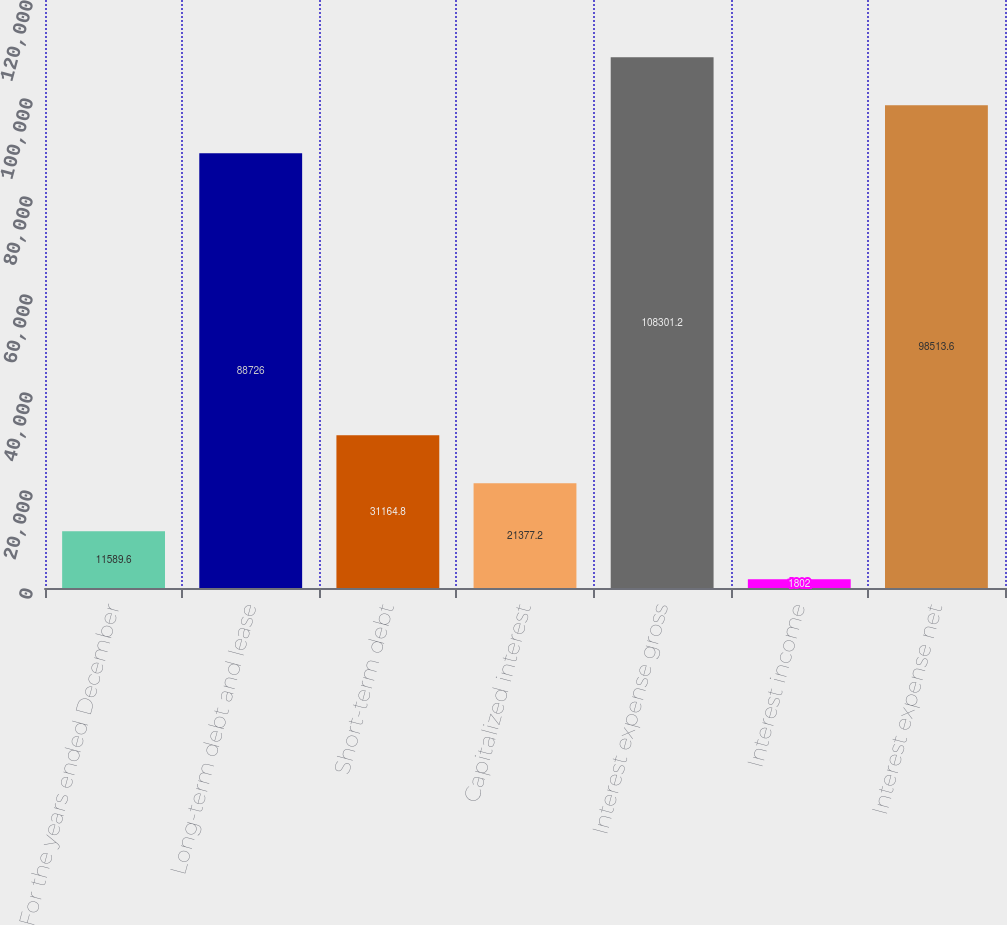<chart> <loc_0><loc_0><loc_500><loc_500><bar_chart><fcel>For the years ended December<fcel>Long-term debt and lease<fcel>Short-term debt<fcel>Capitalized interest<fcel>Interest expense gross<fcel>Interest income<fcel>Interest expense net<nl><fcel>11589.6<fcel>88726<fcel>31164.8<fcel>21377.2<fcel>108301<fcel>1802<fcel>98513.6<nl></chart> 